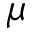<formula> <loc_0><loc_0><loc_500><loc_500>\mu</formula> 